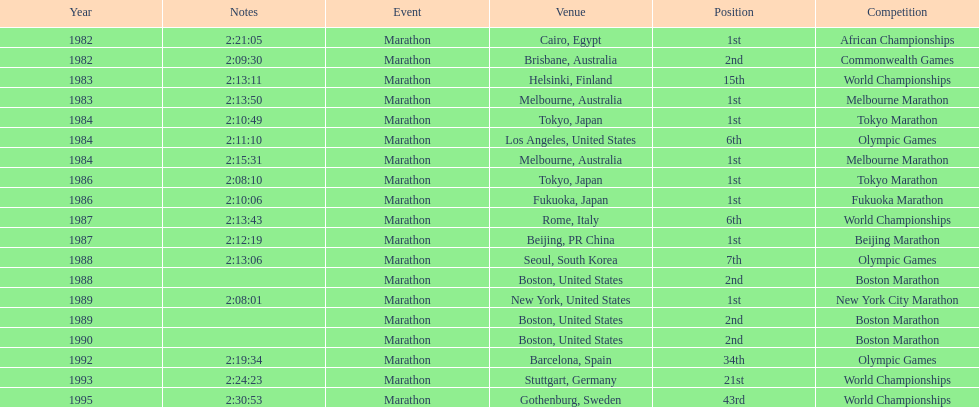In how many instances was the venue based in the united states? 5. 